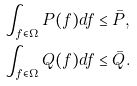Convert formula to latex. <formula><loc_0><loc_0><loc_500><loc_500>& \int _ { f \in \Omega } P ( f ) d f \leq \bar { P } , \\ & \int _ { f \in \Omega } Q ( f ) d f \leq \bar { Q } .</formula> 